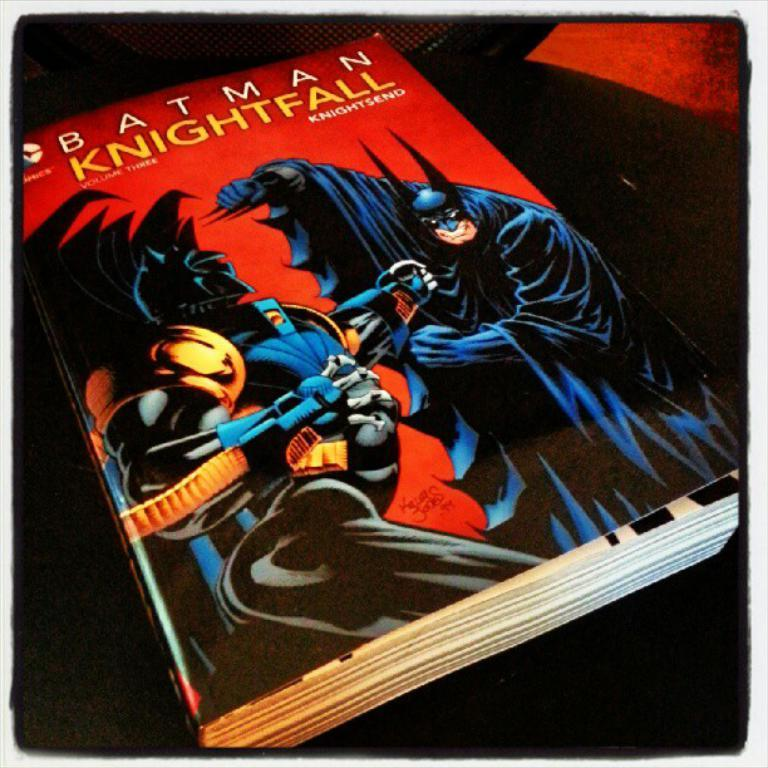<image>
Provide a brief description of the given image. A Batman comic book titled Knightfall volume three. 